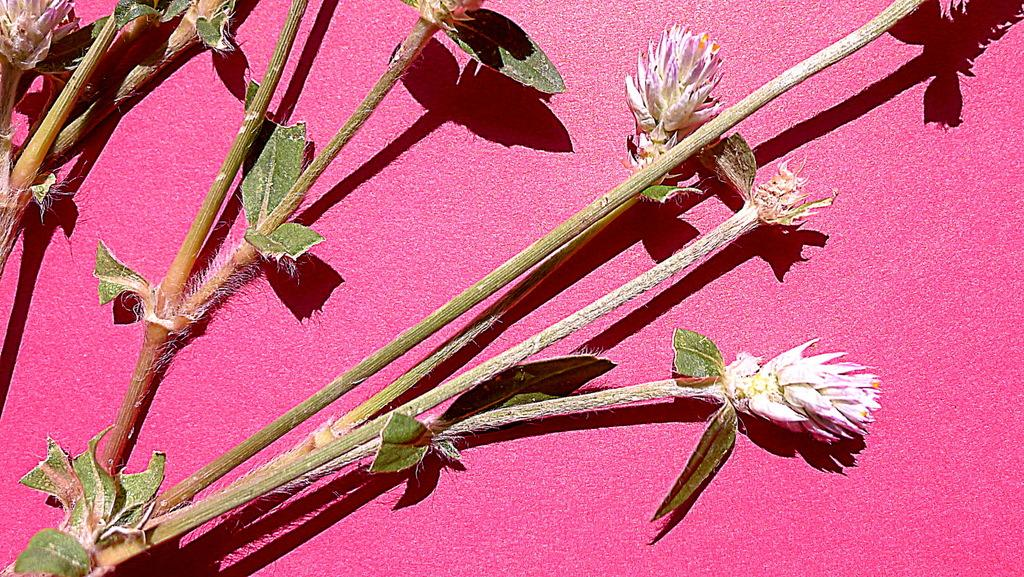What is the main subject of the image? The main subject of the image is a stem of a plant. What parts of the plant can be seen in the image? There are leaves and flowers visible in the image. What color is the background of the image? The background of the image is pink in color. Is there an umbrella visible in the image? No, there is no umbrella present in the image. Can you see any cobwebs on the plant in the image? No, there are no cobwebs visible on the plant in the image. 